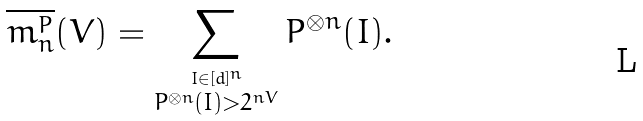<formula> <loc_0><loc_0><loc_500><loc_500>\overline { m _ { n } ^ { P } } ( V ) = \sum _ { \stackrel { I \in [ d ] ^ { n } } { P ^ { \otimes n } ( I ) > 2 ^ { n V } } } P ^ { \otimes n } ( I ) .</formula> 